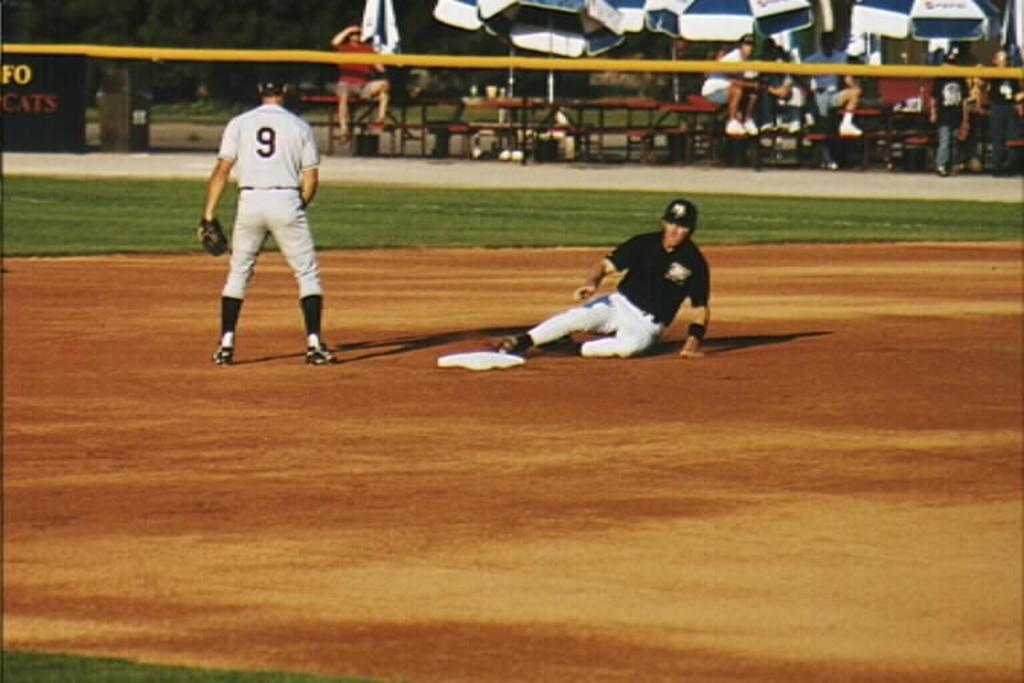<image>
Relay a brief, clear account of the picture shown. Player 9 stands at the base while the other player slides 